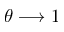Convert formula to latex. <formula><loc_0><loc_0><loc_500><loc_500>\theta \longrightarrow 1</formula> 